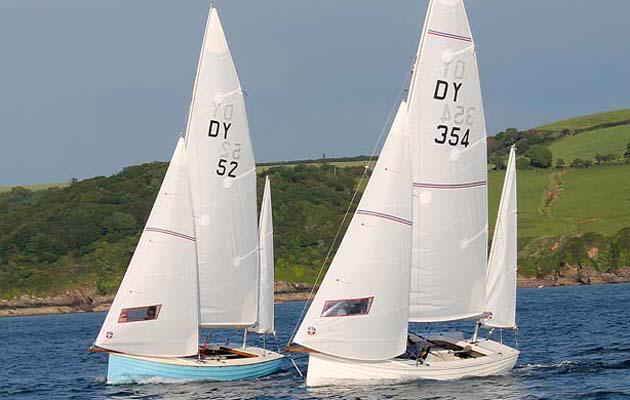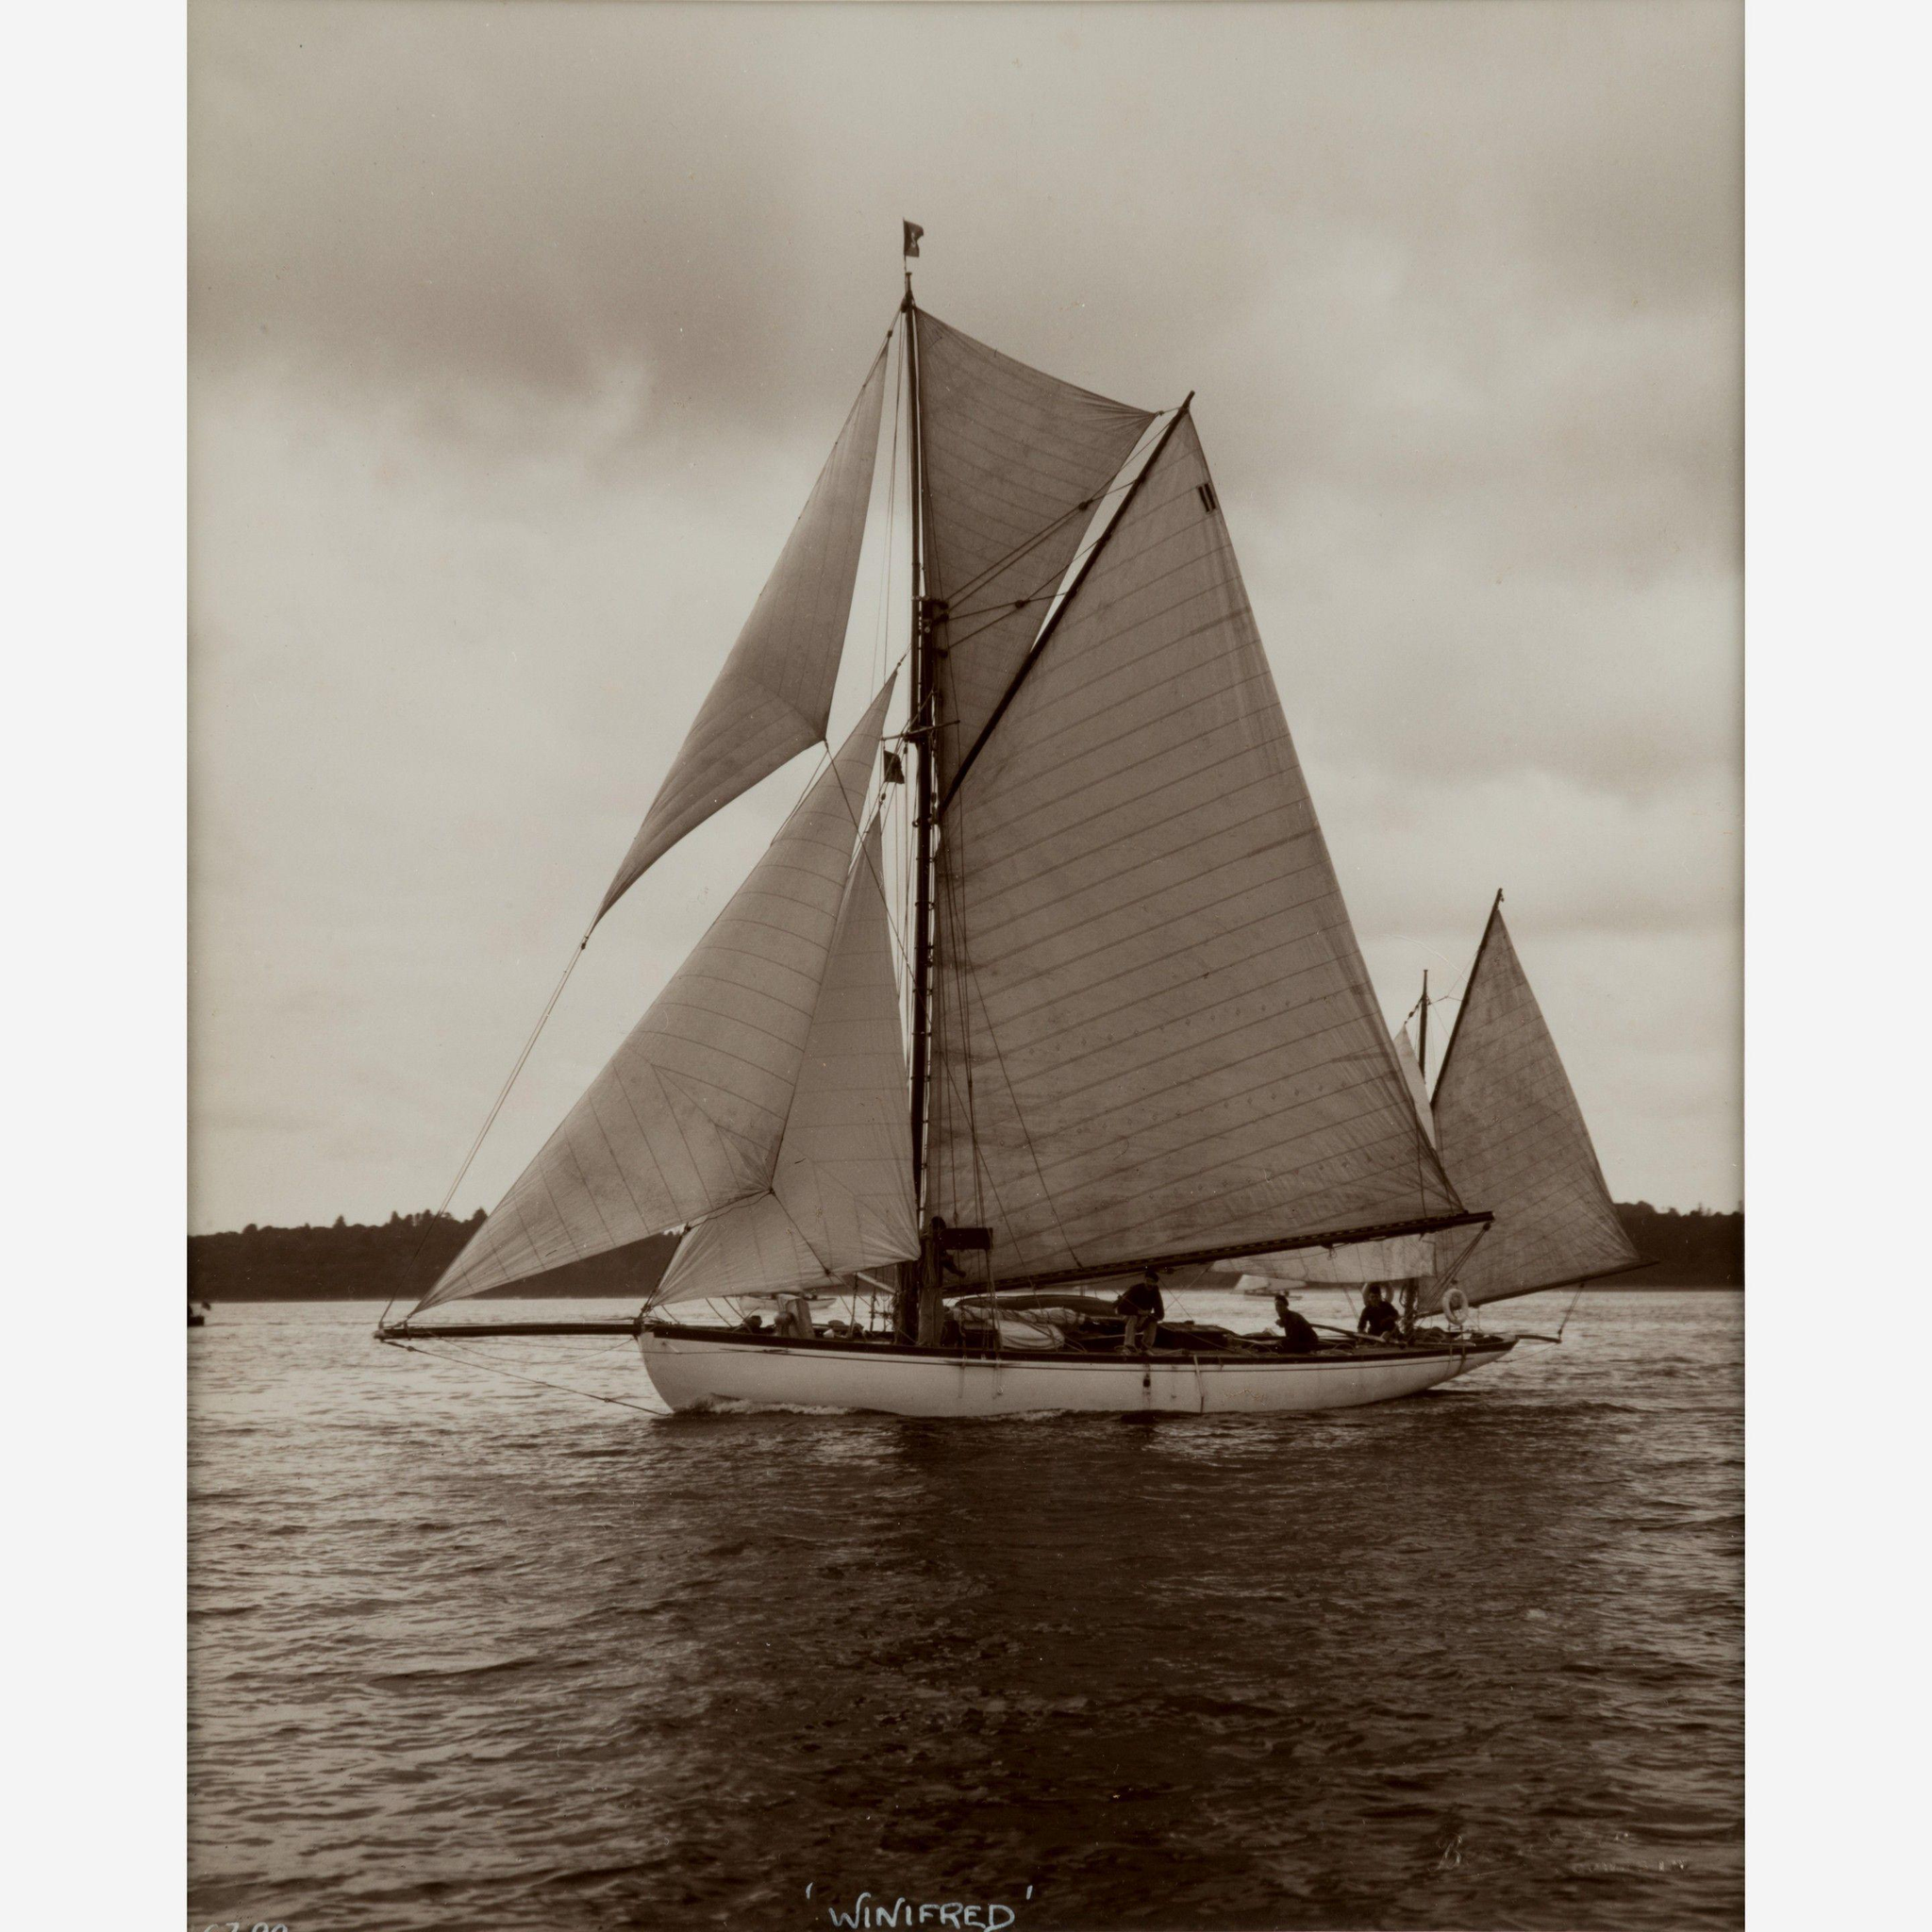The first image is the image on the left, the second image is the image on the right. Examine the images to the left and right. Is the description "A hillside at least half the height of the whole image is in the background of a scene with a sailing boat." accurate? Answer yes or no. Yes. The first image is the image on the left, the second image is the image on the right. Evaluate the accuracy of this statement regarding the images: "One of the images shows a sail with a number on it.". Is it true? Answer yes or no. Yes. 